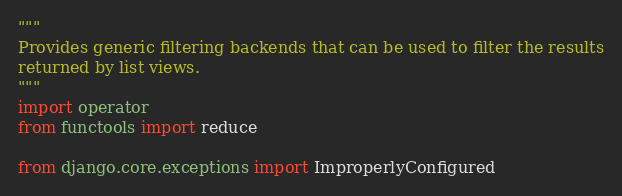<code> <loc_0><loc_0><loc_500><loc_500><_Python_>"""
Provides generic filtering backends that can be used to filter the results
returned by list views.
"""
import operator
from functools import reduce

from django.core.exceptions import ImproperlyConfigured</code> 